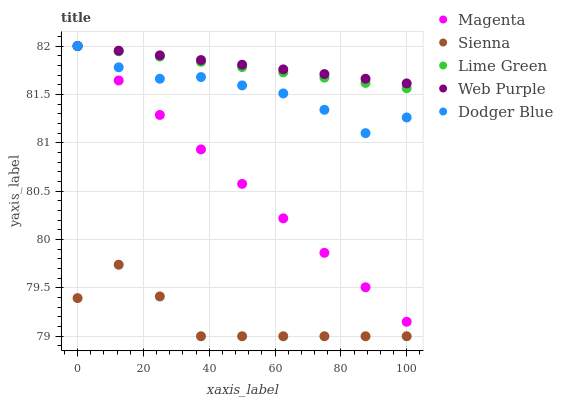Does Sienna have the minimum area under the curve?
Answer yes or no. Yes. Does Web Purple have the maximum area under the curve?
Answer yes or no. Yes. Does Dodger Blue have the minimum area under the curve?
Answer yes or no. No. Does Dodger Blue have the maximum area under the curve?
Answer yes or no. No. Is Magenta the smoothest?
Answer yes or no. Yes. Is Sienna the roughest?
Answer yes or no. Yes. Is Dodger Blue the smoothest?
Answer yes or no. No. Is Dodger Blue the roughest?
Answer yes or no. No. Does Sienna have the lowest value?
Answer yes or no. Yes. Does Dodger Blue have the lowest value?
Answer yes or no. No. Does Web Purple have the highest value?
Answer yes or no. Yes. Is Sienna less than Lime Green?
Answer yes or no. Yes. Is Magenta greater than Sienna?
Answer yes or no. Yes. Does Dodger Blue intersect Lime Green?
Answer yes or no. Yes. Is Dodger Blue less than Lime Green?
Answer yes or no. No. Is Dodger Blue greater than Lime Green?
Answer yes or no. No. Does Sienna intersect Lime Green?
Answer yes or no. No. 